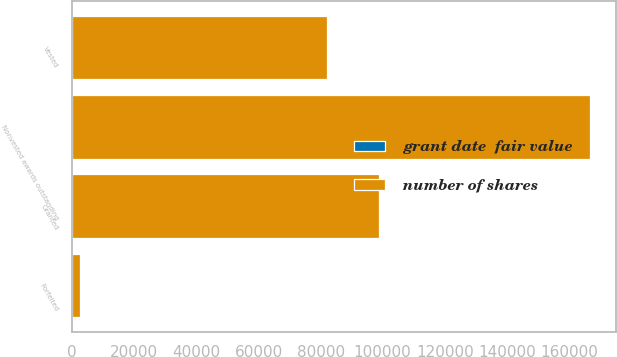Convert chart. <chart><loc_0><loc_0><loc_500><loc_500><stacked_bar_chart><ecel><fcel>Nonvested awards outstanding<fcel>Granted<fcel>Vested<fcel>Forfeited<nl><fcel>number of shares<fcel>166700<fcel>98900<fcel>82000<fcel>2300<nl><fcel>grant date  fair value<fcel>46.32<fcel>47.53<fcel>42.88<fcel>46.4<nl></chart> 